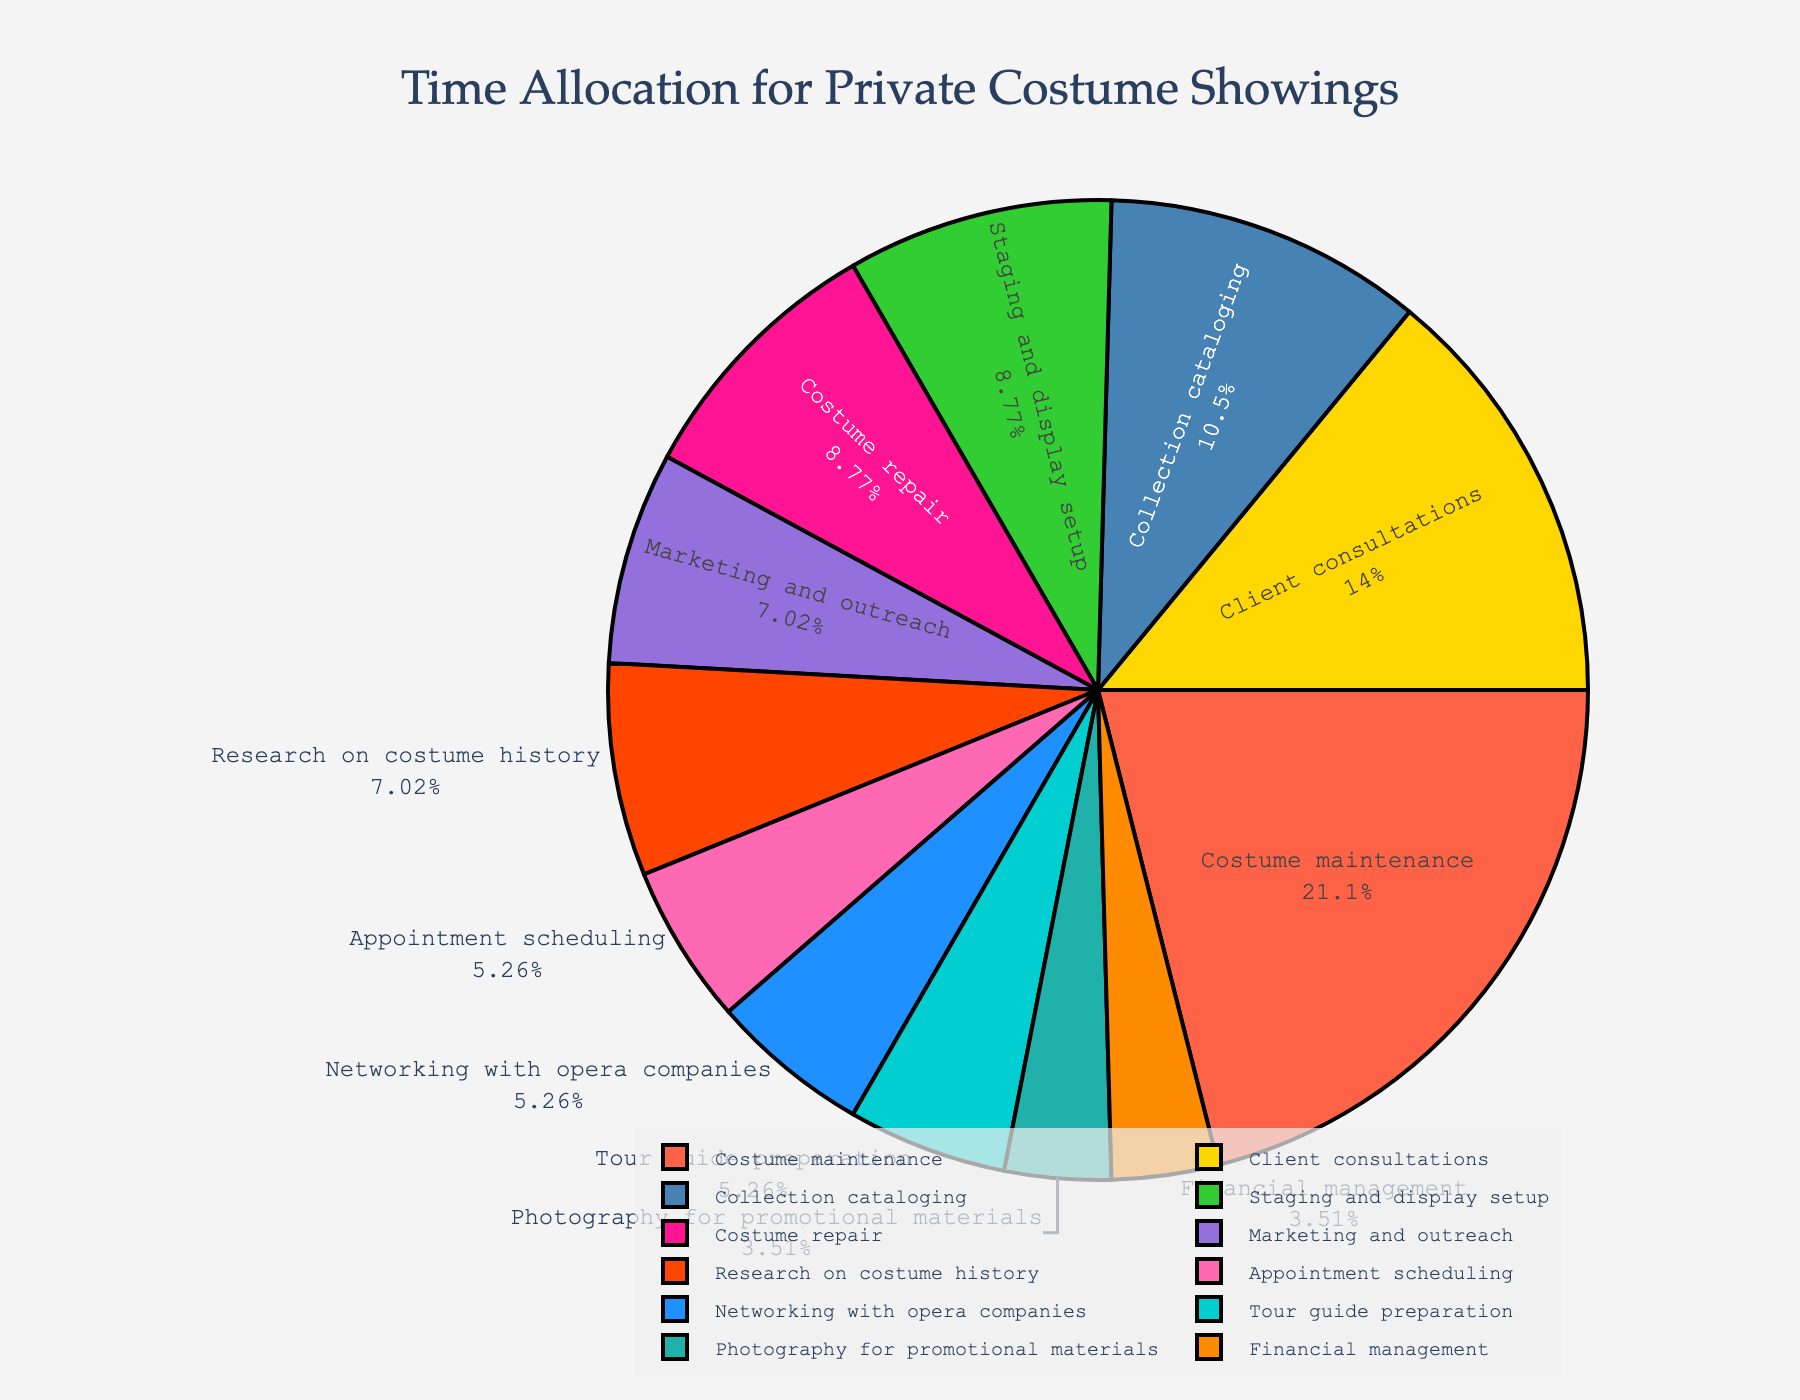Which activity takes up the most time each week? By looking at the pie chart, the segment with the largest area corresponds to the activity that takes up the most time each week.
Answer: Costume maintenance What's the total time spent on client consultations and marketing and outreach? The chart shows that client consultations take 8 hours per week and marketing and outreach take 4 hours per week. Adding these together gives 8 + 4.
Answer: 12 hours Which two activities combined take equal time as costume repair? Costume repair takes 5 hours per week. Staging and display setup (5 hours) matches this exactly, as 5 equals 5.
Answer: Staging and display setup Is more time spent on research on costume history or networking with opera companies? The pie chart shows that research on costume history takes 4 hours per week, while networking with opera companies takes 3 hours per week.
Answer: Research on costume history What percentage of the week is spent on collection cataloging? The pie chart provides both hour values and percentage values. Collection cataloging is displayed as a certain percentage of the total weekly time.
Answer: Approximately 11.5% How much more time is spent on costume maintenance compared to financial management? According to the chart, costume maintenance is 12 hours per week and financial management is 2 hours per week. Subtracting these gives 12 - 2.
Answer: 10 hours If the hours spent on client consultations doubled, would it surpass the hours spent on costume maintenance? Doubling the time on client consultations gives 8 * 2 = 16 hours, while costume maintenance is 12 hours per week. Thus, 16 is greater than 12.
Answer: Yes What is the combined time spent on appointment scheduling, tour guide preparation, and financial management? Adding the hours for these activities: 3 (appointment scheduling) + 3 (tour guide preparation) + 2 (financial management) gives 3 + 3 + 2.
Answer: 8 hours Which activity has the smallest time allocation? By observing the smallest segment in the pie chart, the activity with the smallest portion corresponds to 2 hours which is assigned to photography for promotional materials and financial management.
Answer: Photography for promotional materials and financial management Are more hours spent on staging and display setup or costume repair? According to the chart, staging and display setup is 5 hours per week, and costume repair is also 5 hours per week.
Answer: Equal 